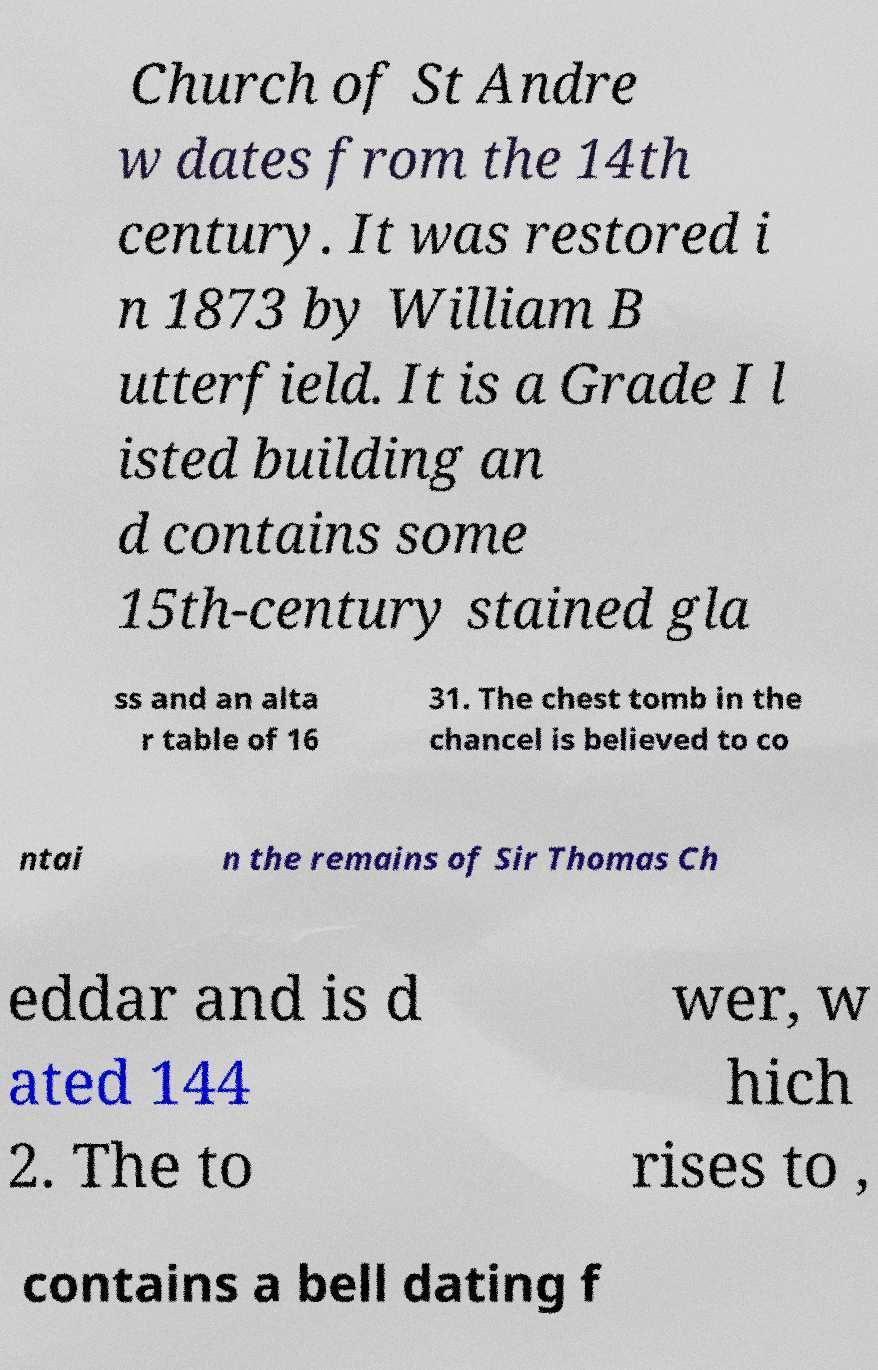Could you assist in decoding the text presented in this image and type it out clearly? Church of St Andre w dates from the 14th century. It was restored i n 1873 by William B utterfield. It is a Grade I l isted building an d contains some 15th-century stained gla ss and an alta r table of 16 31. The chest tomb in the chancel is believed to co ntai n the remains of Sir Thomas Ch eddar and is d ated 144 2. The to wer, w hich rises to , contains a bell dating f 